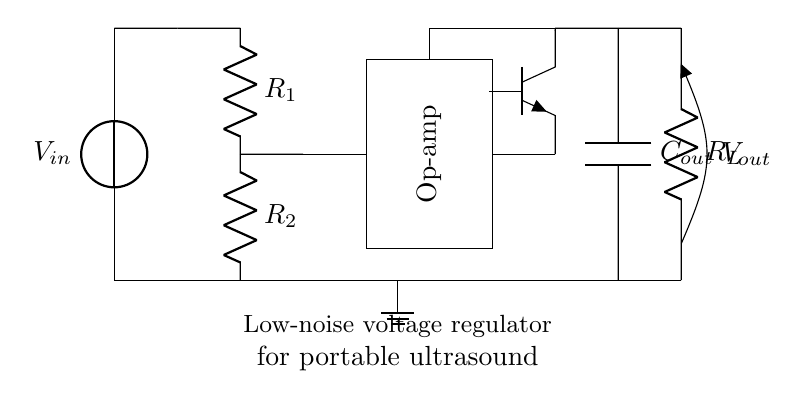What is the type of voltage regulator used in this circuit? The circuit diagram depicts a low-dropout regulator, indicated by the components and design meant for efficient voltage regulation with minimal drop.
Answer: low-dropout regulator What is the purpose of the op-amp in this regulator circuit? The operational amplifier in this circuit functions to provide feedback control for the regulation, ensuring stable output voltage despite variations in input or load conditions.
Answer: feedback control How many resistors are present in the circuit? There are two resistors labeled as R1 and R2 in the circuit, used in conjunction with the regulator to set the output voltage level.
Answer: two What is the function of the output capacitor labeled as Cout? The output capacitor helps filter and stabilize the output voltage, reducing noise and ensuring a smooth voltage delivery to the load.
Answer: filter and stabilize What type of transistor is used in this circuit? The schematic shows an npn transistor, which is a common choice in low-dropout regulator designs for current amplification and switching.
Answer: npn How does R1 and R2 relate to the output voltage? R1 and R2 form a voltage divider that sets the output voltage based on their resistance values in relation to the input voltage supplied.
Answer: voltage divider What is the expected behavior of the voltage regulator under varying load conditions? The low-dropout design is intended to maintain a constant output voltage even as the load changes, a key feature for devices like portable ultrasound machines.
Answer: maintain constant voltage 